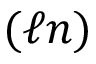<formula> <loc_0><loc_0><loc_500><loc_500>( \ell n )</formula> 